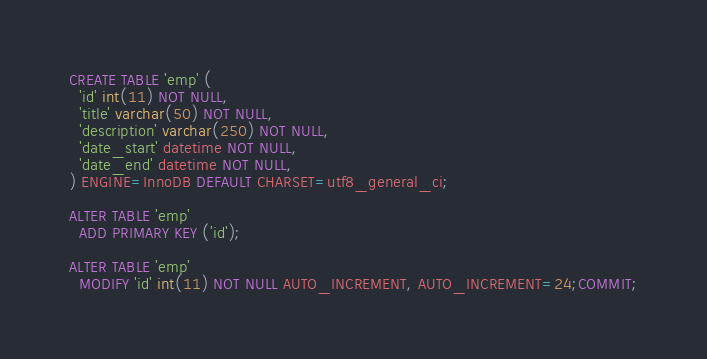<code> <loc_0><loc_0><loc_500><loc_500><_SQL_>CREATE TABLE 'emp' (
  'id' int(11) NOT NULL,
  'title' varchar(50) NOT NULL,
  'description' varchar(250) NOT NULL,
  'date_start' datetime NOT NULL,
  'date_end' datetime NOT NULL,
) ENGINE=InnoDB DEFAULT CHARSET=utf8_general_ci;

ALTER TABLE 'emp'
  ADD PRIMARY KEY ('id');

ALTER TABLE 'emp'
  MODIFY 'id' int(11) NOT NULL AUTO_INCREMENT, AUTO_INCREMENT=24;COMMIT;</code> 